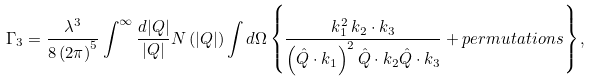Convert formula to latex. <formula><loc_0><loc_0><loc_500><loc_500>\Gamma _ { 3 } = \frac { \lambda ^ { 3 } } { 8 \left ( 2 \pi \right ) ^ { 5 } } \int ^ { \infty } \frac { d | { Q } | } { | { Q } | } N \left ( | { Q } | \right ) \int d \Omega \left \{ \frac { k _ { 1 } ^ { 2 } \, k _ { 2 } \cdot k _ { 3 } } { \left ( \hat { Q } \cdot k _ { 1 } \right ) ^ { 2 } \hat { Q } \cdot k _ { 2 } \hat { Q } \cdot k _ { 3 } } + p e r m u t a t i o n s \right \} ,</formula> 